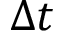<formula> <loc_0><loc_0><loc_500><loc_500>\Delta t</formula> 